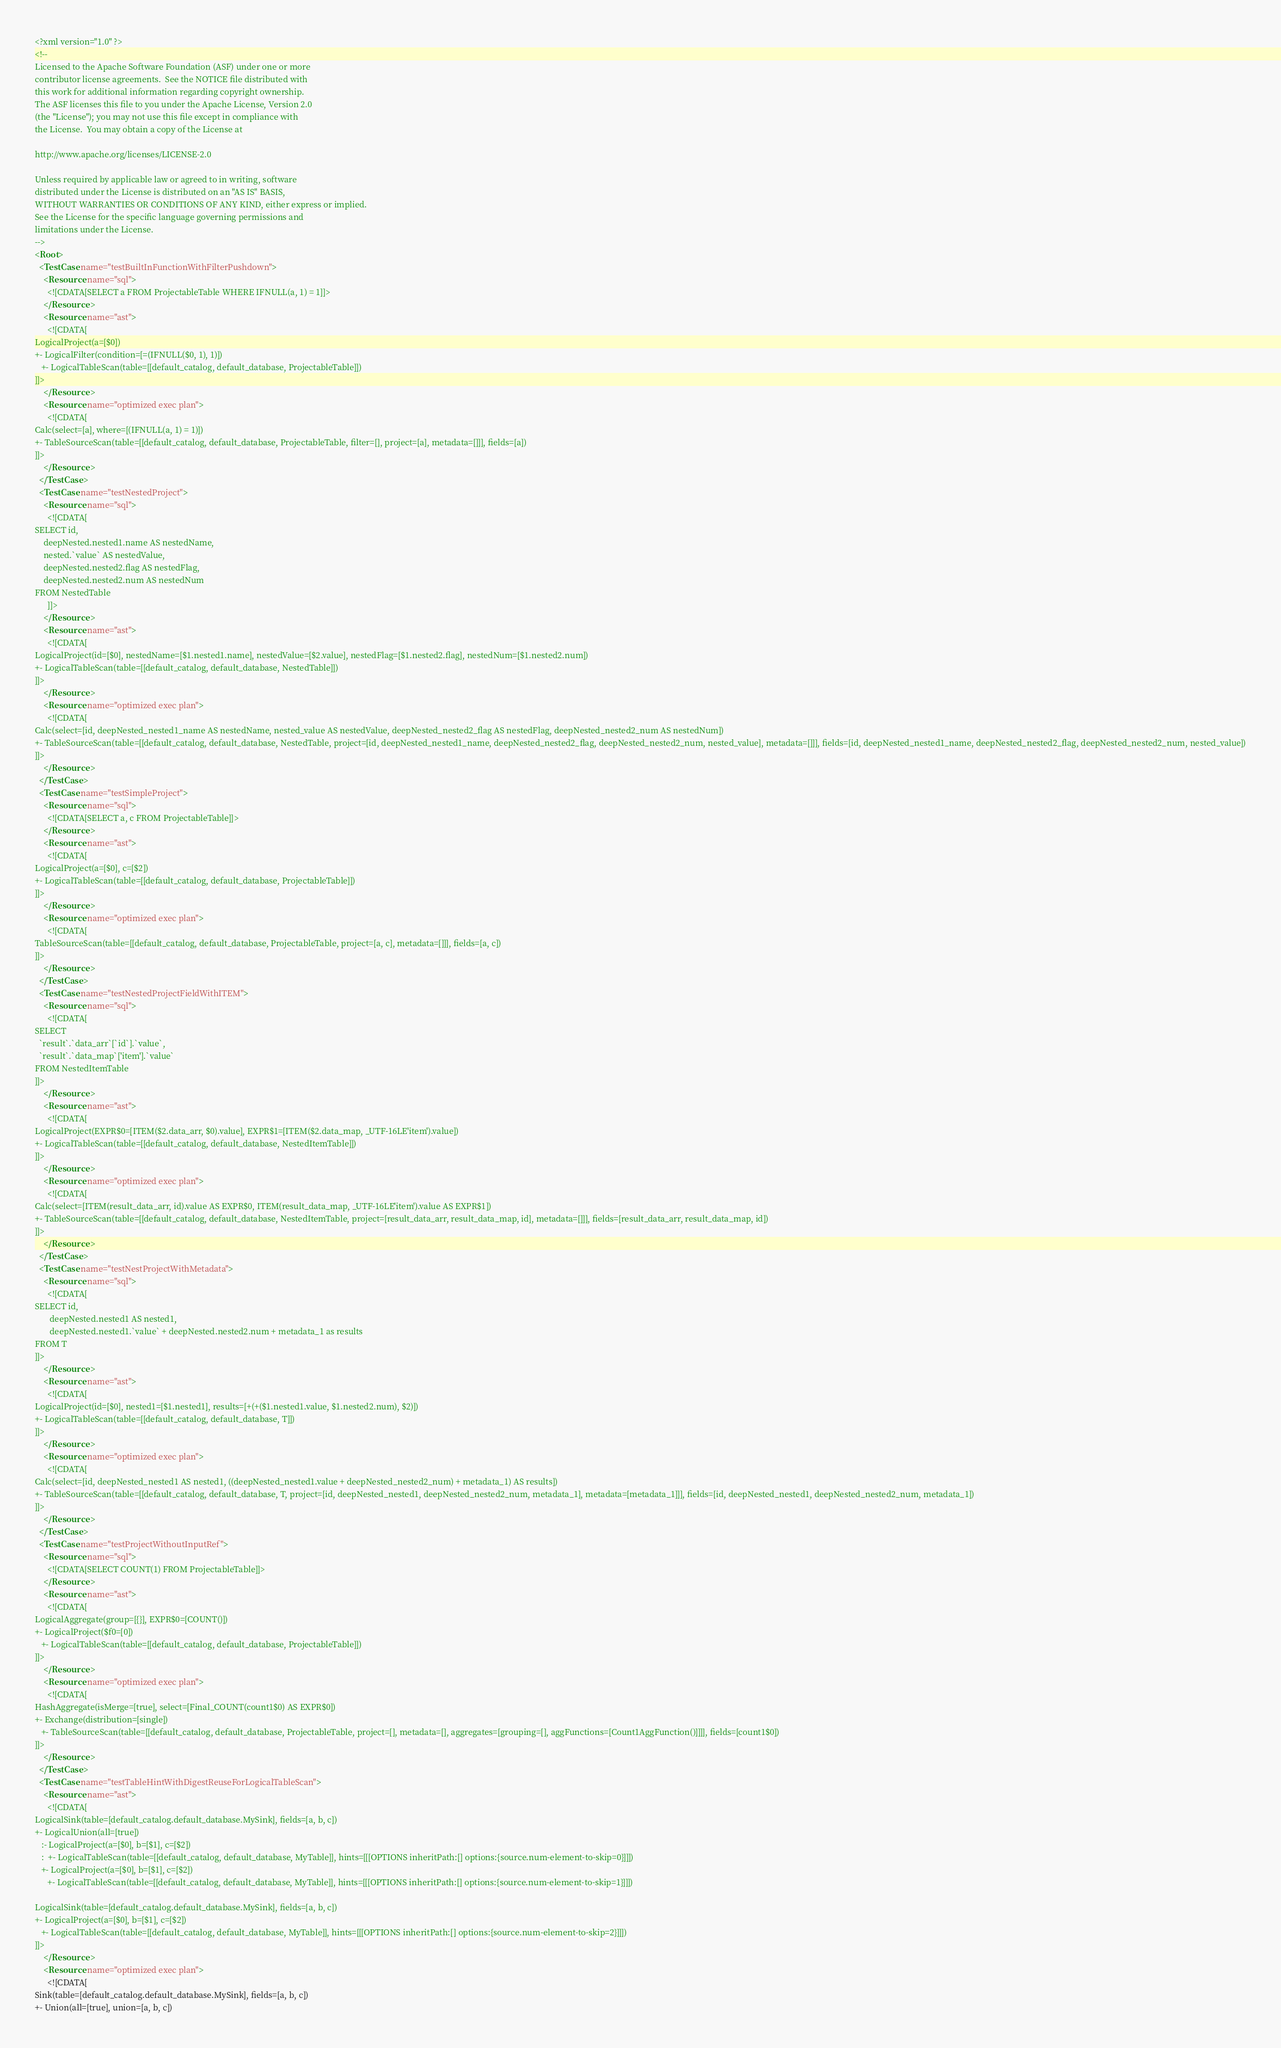Convert code to text. <code><loc_0><loc_0><loc_500><loc_500><_XML_><?xml version="1.0" ?>
<!--
Licensed to the Apache Software Foundation (ASF) under one or more
contributor license agreements.  See the NOTICE file distributed with
this work for additional information regarding copyright ownership.
The ASF licenses this file to you under the Apache License, Version 2.0
(the "License"); you may not use this file except in compliance with
the License.  You may obtain a copy of the License at

http://www.apache.org/licenses/LICENSE-2.0

Unless required by applicable law or agreed to in writing, software
distributed under the License is distributed on an "AS IS" BASIS,
WITHOUT WARRANTIES OR CONDITIONS OF ANY KIND, either express or implied.
See the License for the specific language governing permissions and
limitations under the License.
-->
<Root>
  <TestCase name="testBuiltInFunctionWithFilterPushdown">
    <Resource name="sql">
      <![CDATA[SELECT a FROM ProjectableTable WHERE IFNULL(a, 1) = 1]]>
    </Resource>
    <Resource name="ast">
      <![CDATA[
LogicalProject(a=[$0])
+- LogicalFilter(condition=[=(IFNULL($0, 1), 1)])
   +- LogicalTableScan(table=[[default_catalog, default_database, ProjectableTable]])
]]>
    </Resource>
    <Resource name="optimized exec plan">
      <![CDATA[
Calc(select=[a], where=[(IFNULL(a, 1) = 1)])
+- TableSourceScan(table=[[default_catalog, default_database, ProjectableTable, filter=[], project=[a], metadata=[]]], fields=[a])
]]>
    </Resource>
  </TestCase>
  <TestCase name="testNestedProject">
    <Resource name="sql">
      <![CDATA[
SELECT id,
    deepNested.nested1.name AS nestedName,
    nested.`value` AS nestedValue,
    deepNested.nested2.flag AS nestedFlag,
    deepNested.nested2.num AS nestedNum
FROM NestedTable
      ]]>
    </Resource>
    <Resource name="ast">
      <![CDATA[
LogicalProject(id=[$0], nestedName=[$1.nested1.name], nestedValue=[$2.value], nestedFlag=[$1.nested2.flag], nestedNum=[$1.nested2.num])
+- LogicalTableScan(table=[[default_catalog, default_database, NestedTable]])
]]>
    </Resource>
    <Resource name="optimized exec plan">
      <![CDATA[
Calc(select=[id, deepNested_nested1_name AS nestedName, nested_value AS nestedValue, deepNested_nested2_flag AS nestedFlag, deepNested_nested2_num AS nestedNum])
+- TableSourceScan(table=[[default_catalog, default_database, NestedTable, project=[id, deepNested_nested1_name, deepNested_nested2_flag, deepNested_nested2_num, nested_value], metadata=[]]], fields=[id, deepNested_nested1_name, deepNested_nested2_flag, deepNested_nested2_num, nested_value])
]]>
    </Resource>
  </TestCase>
  <TestCase name="testSimpleProject">
    <Resource name="sql">
      <![CDATA[SELECT a, c FROM ProjectableTable]]>
    </Resource>
    <Resource name="ast">
      <![CDATA[
LogicalProject(a=[$0], c=[$2])
+- LogicalTableScan(table=[[default_catalog, default_database, ProjectableTable]])
]]>
    </Resource>
    <Resource name="optimized exec plan">
      <![CDATA[
TableSourceScan(table=[[default_catalog, default_database, ProjectableTable, project=[a, c], metadata=[]]], fields=[a, c])
]]>
    </Resource>
  </TestCase>
  <TestCase name="testNestedProjectFieldWithITEM">
    <Resource name="sql">
      <![CDATA[
SELECT
  `result`.`data_arr`[`id`].`value`,
  `result`.`data_map`['item'].`value`
FROM NestedItemTable
]]>
    </Resource>
    <Resource name="ast">
      <![CDATA[
LogicalProject(EXPR$0=[ITEM($2.data_arr, $0).value], EXPR$1=[ITEM($2.data_map, _UTF-16LE'item').value])
+- LogicalTableScan(table=[[default_catalog, default_database, NestedItemTable]])
]]>
    </Resource>
    <Resource name="optimized exec plan">
      <![CDATA[
Calc(select=[ITEM(result_data_arr, id).value AS EXPR$0, ITEM(result_data_map, _UTF-16LE'item').value AS EXPR$1])
+- TableSourceScan(table=[[default_catalog, default_database, NestedItemTable, project=[result_data_arr, result_data_map, id], metadata=[]]], fields=[result_data_arr, result_data_map, id])
]]>
    </Resource>
  </TestCase>
  <TestCase name="testNestProjectWithMetadata">
    <Resource name="sql">
      <![CDATA[
SELECT id,
       deepNested.nested1 AS nested1,
       deepNested.nested1.`value` + deepNested.nested2.num + metadata_1 as results
FROM T
]]>
    </Resource>
    <Resource name="ast">
      <![CDATA[
LogicalProject(id=[$0], nested1=[$1.nested1], results=[+(+($1.nested1.value, $1.nested2.num), $2)])
+- LogicalTableScan(table=[[default_catalog, default_database, T]])
]]>
    </Resource>
    <Resource name="optimized exec plan">
      <![CDATA[
Calc(select=[id, deepNested_nested1 AS nested1, ((deepNested_nested1.value + deepNested_nested2_num) + metadata_1) AS results])
+- TableSourceScan(table=[[default_catalog, default_database, T, project=[id, deepNested_nested1, deepNested_nested2_num, metadata_1], metadata=[metadata_1]]], fields=[id, deepNested_nested1, deepNested_nested2_num, metadata_1])
]]>
    </Resource>
  </TestCase>
  <TestCase name="testProjectWithoutInputRef">
    <Resource name="sql">
      <![CDATA[SELECT COUNT(1) FROM ProjectableTable]]>
    </Resource>
    <Resource name="ast">
      <![CDATA[
LogicalAggregate(group=[{}], EXPR$0=[COUNT()])
+- LogicalProject($f0=[0])
   +- LogicalTableScan(table=[[default_catalog, default_database, ProjectableTable]])
]]>
    </Resource>
    <Resource name="optimized exec plan">
      <![CDATA[
HashAggregate(isMerge=[true], select=[Final_COUNT(count1$0) AS EXPR$0])
+- Exchange(distribution=[single])
   +- TableSourceScan(table=[[default_catalog, default_database, ProjectableTable, project=[], metadata=[], aggregates=[grouping=[], aggFunctions=[Count1AggFunction()]]]], fields=[count1$0])
]]>
    </Resource>
  </TestCase>
  <TestCase name="testTableHintWithDigestReuseForLogicalTableScan">
    <Resource name="ast">
      <![CDATA[
LogicalSink(table=[default_catalog.default_database.MySink], fields=[a, b, c])
+- LogicalUnion(all=[true])
   :- LogicalProject(a=[$0], b=[$1], c=[$2])
   :  +- LogicalTableScan(table=[[default_catalog, default_database, MyTable]], hints=[[[OPTIONS inheritPath:[] options:{source.num-element-to-skip=0}]]])
   +- LogicalProject(a=[$0], b=[$1], c=[$2])
      +- LogicalTableScan(table=[[default_catalog, default_database, MyTable]], hints=[[[OPTIONS inheritPath:[] options:{source.num-element-to-skip=1}]]])

LogicalSink(table=[default_catalog.default_database.MySink], fields=[a, b, c])
+- LogicalProject(a=[$0], b=[$1], c=[$2])
   +- LogicalTableScan(table=[[default_catalog, default_database, MyTable]], hints=[[[OPTIONS inheritPath:[] options:{source.num-element-to-skip=2}]]])
]]>
    </Resource>
    <Resource name="optimized exec plan">
      <![CDATA[
Sink(table=[default_catalog.default_database.MySink], fields=[a, b, c])
+- Union(all=[true], union=[a, b, c])</code> 